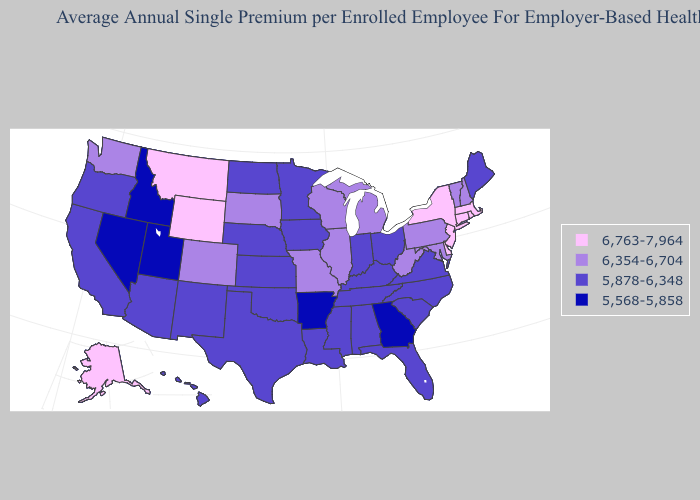What is the value of Oklahoma?
Be succinct. 5,878-6,348. Name the states that have a value in the range 6,763-7,964?
Quick response, please. Alaska, Connecticut, Delaware, Massachusetts, Montana, New Jersey, New York, Rhode Island, Wyoming. Does Idaho have a lower value than Arkansas?
Answer briefly. No. Does Ohio have the lowest value in the USA?
Answer briefly. No. Among the states that border Tennessee , does Missouri have the highest value?
Give a very brief answer. Yes. Does the first symbol in the legend represent the smallest category?
Short answer required. No. Name the states that have a value in the range 6,763-7,964?
Quick response, please. Alaska, Connecticut, Delaware, Massachusetts, Montana, New Jersey, New York, Rhode Island, Wyoming. Name the states that have a value in the range 6,763-7,964?
Answer briefly. Alaska, Connecticut, Delaware, Massachusetts, Montana, New Jersey, New York, Rhode Island, Wyoming. Name the states that have a value in the range 6,354-6,704?
Be succinct. Colorado, Illinois, Maryland, Michigan, Missouri, New Hampshire, Pennsylvania, South Dakota, Vermont, Washington, West Virginia, Wisconsin. What is the value of New Mexico?
Write a very short answer. 5,878-6,348. What is the value of North Dakota?
Keep it brief. 5,878-6,348. What is the value of Georgia?
Keep it brief. 5,568-5,858. Among the states that border South Dakota , does Montana have the lowest value?
Answer briefly. No. Name the states that have a value in the range 6,354-6,704?
Answer briefly. Colorado, Illinois, Maryland, Michigan, Missouri, New Hampshire, Pennsylvania, South Dakota, Vermont, Washington, West Virginia, Wisconsin. What is the value of Illinois?
Be succinct. 6,354-6,704. 